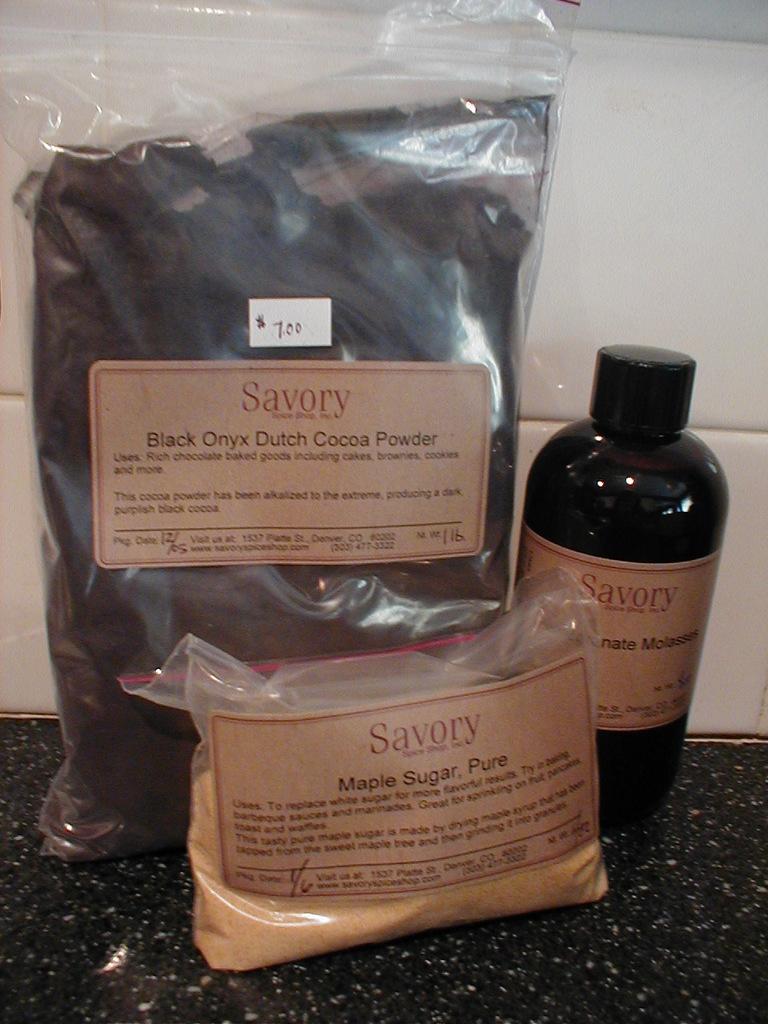What is in the large bag that is behind the smaller bag?
Your response must be concise. Black onyx dutch cocoa powder. Which company makes these products?
Ensure brevity in your answer.  Savory. 